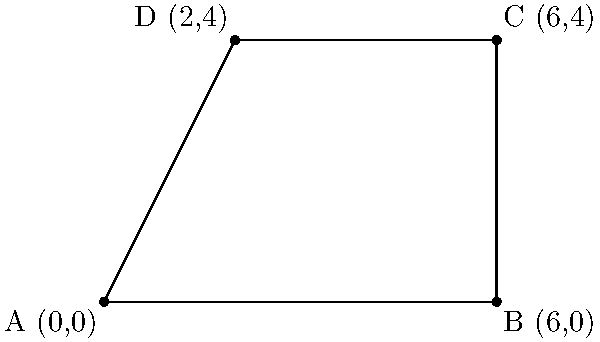A newly established protected wildlife habitat is represented by the quadrilateral ABCD in the coordinate system above. The coordinates of the vertices are A(0,0), B(6,0), C(6,4), and D(2,4). Calculate the area of this habitat to determine the extent of the protected region. How many square units of land are dedicated to preserving wildlife in this area? To find the area of the quadrilateral ABCD, we can divide it into two triangles and calculate their areas separately:

1. Triangle ABD:
   Base (AB) = 6 units
   Height (perpendicular from D to AB) = 4 units
   Area of ABD = $\frac{1}{2} \times base \times height = \frac{1}{2} \times 6 \times 4 = 12$ square units

2. Triangle BCD:
   Base (BC) = 4 units
   Height (perpendicular from D to BC) = 4 units
   Area of BCD = $\frac{1}{2} \times base \times height = \frac{1}{2} \times 4 \times 4 = 8$ square units

3. Total area:
   Area of ABCD = Area of ABD + Area of BCD
                = 12 + 8 = 20 square units

Alternatively, we could use the shoelace formula:
$$Area = \frac{1}{2}|(x_1y_2 + x_2y_3 + x_3y_4 + x_4y_1) - (y_1x_2 + y_2x_3 + y_3x_4 + y_4x_1)|$$

Substituting the coordinates:
$$Area = \frac{1}{2}|(0 \times 0 + 6 \times 4 + 6 \times 4 + 2 \times 0) - (0 \times 6 + 0 \times 6 + 4 \times 2 + 4 \times 0)|$$
$$= \frac{1}{2}|(0 + 24 + 24 + 0) - (0 + 0 + 8 + 0)|$$
$$= \frac{1}{2}|48 - 8| = \frac{1}{2} \times 40 = 20$$ square units

Therefore, the area of the protected wildlife habitat is 20 square units.
Answer: 20 square units 